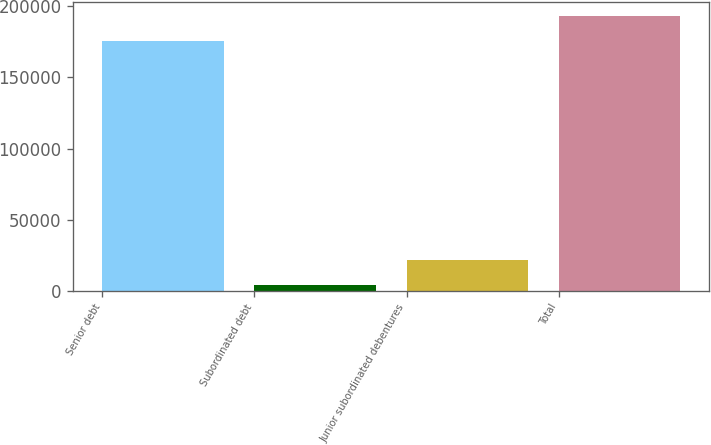Convert chart. <chart><loc_0><loc_0><loc_500><loc_500><bar_chart><fcel>Senior debt<fcel>Subordinated debt<fcel>Junior subordinated debentures<fcel>Total<nl><fcel>175471<fcel>3910<fcel>21942.4<fcel>193503<nl></chart> 